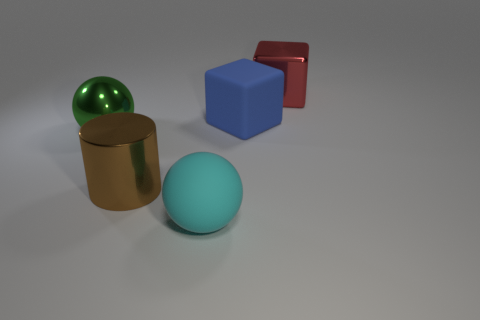Add 4 big brown cylinders. How many objects exist? 9 Subtract all balls. How many objects are left? 3 Subtract all tiny red cubes. Subtract all red metallic objects. How many objects are left? 4 Add 2 rubber cubes. How many rubber cubes are left? 3 Add 2 small yellow metal cubes. How many small yellow metal cubes exist? 2 Subtract 0 red spheres. How many objects are left? 5 